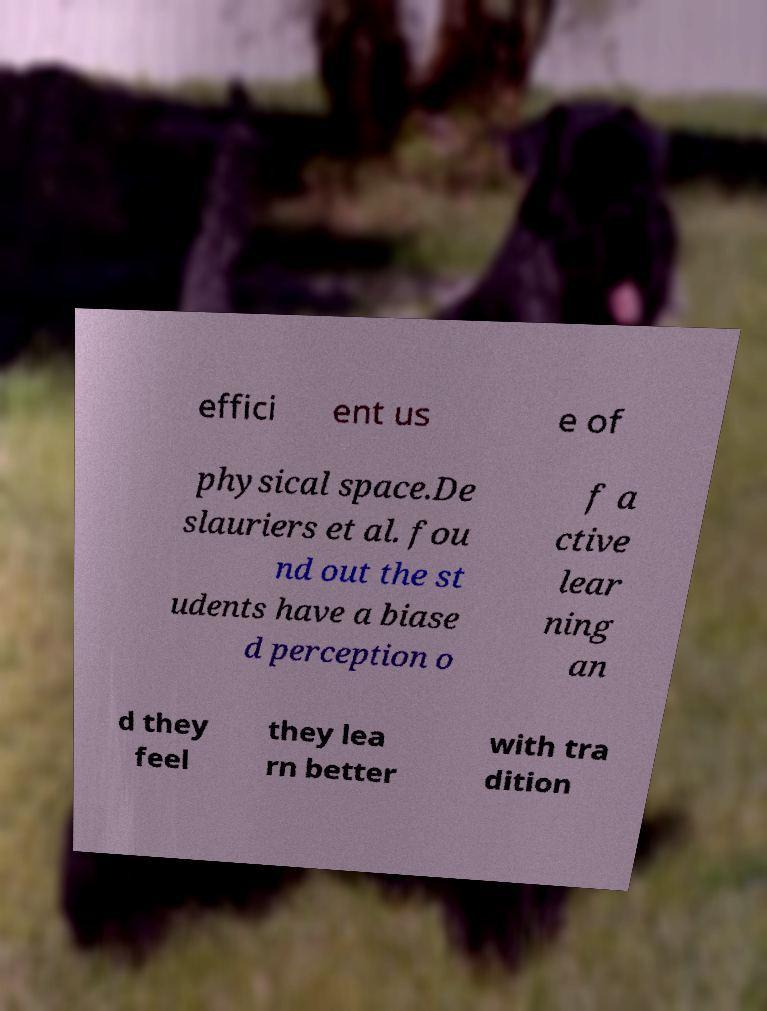Could you extract and type out the text from this image? effici ent us e of physical space.De slauriers et al. fou nd out the st udents have a biase d perception o f a ctive lear ning an d they feel they lea rn better with tra dition 